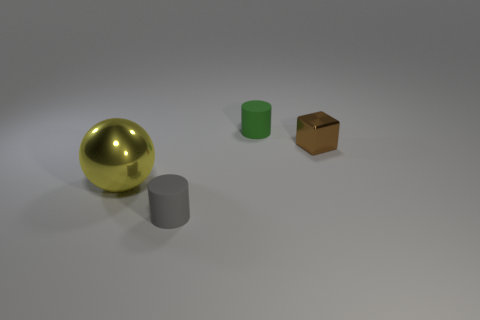Is there any other thing that has the same shape as the yellow metallic object?
Offer a terse response. No. The thing that is right of the small matte object that is right of the tiny gray matte cylinder is what shape?
Make the answer very short. Cube. What is the shape of the small green rubber thing?
Make the answer very short. Cylinder. The cylinder that is behind the brown shiny cube behind the metallic thing that is on the left side of the tiny gray object is made of what material?
Make the answer very short. Rubber. What number of other things are there of the same material as the small green cylinder
Provide a succinct answer. 1. How many cylinders are on the right side of the rubber cylinder in front of the brown metal cube?
Make the answer very short. 1. What number of blocks are either small gray things or metallic things?
Offer a terse response. 1. What color is the object that is behind the gray cylinder and left of the small green rubber cylinder?
Your answer should be compact. Yellow. Is there anything else that is the same color as the small metallic cube?
Provide a succinct answer. No. What color is the tiny cylinder that is right of the cylinder that is in front of the ball?
Your response must be concise. Green. 